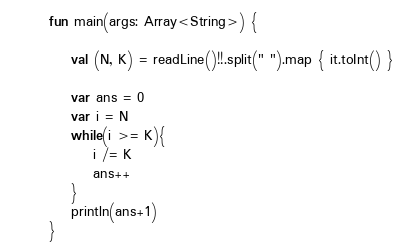Convert code to text. <code><loc_0><loc_0><loc_500><loc_500><_Kotlin_>fun main(args: Array<String>) {

    val (N, K) = readLine()!!.split(" ").map { it.toInt() }

    var ans = 0
    var i = N
    while(i >= K){
        i /= K
        ans++
    }
    println(ans+1)
}</code> 